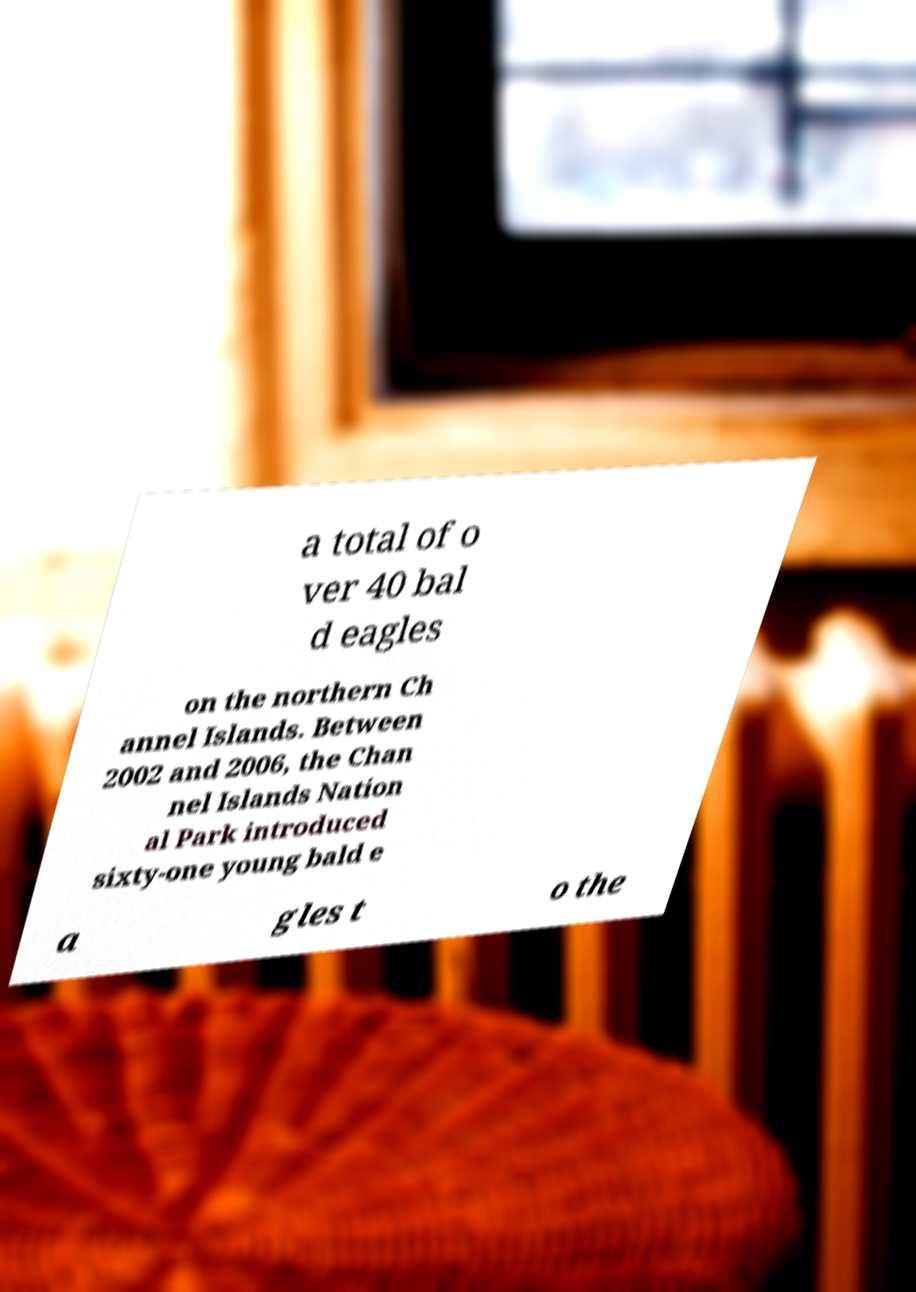What messages or text are displayed in this image? I need them in a readable, typed format. a total of o ver 40 bal d eagles on the northern Ch annel Islands. Between 2002 and 2006, the Chan nel Islands Nation al Park introduced sixty-one young bald e a gles t o the 